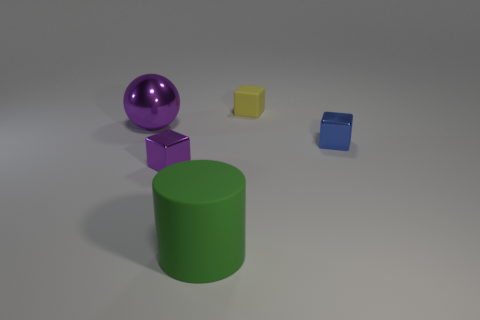How many cyan objects are tiny shiny cubes or metallic objects?
Offer a terse response. 0. The ball has what color?
Provide a short and direct response. Purple. Are there any other things that are the same material as the yellow object?
Keep it short and to the point. Yes. Is the number of cylinders in front of the green rubber cylinder less than the number of yellow rubber blocks that are on the left side of the large metallic thing?
Keep it short and to the point. No. The object that is both in front of the tiny blue thing and behind the matte cylinder has what shape?
Ensure brevity in your answer.  Cube. How many purple metal objects are the same shape as the tiny yellow rubber object?
Give a very brief answer. 1. The ball that is the same material as the blue object is what size?
Your answer should be very brief. Large. How many other blocks are the same size as the matte block?
Make the answer very short. 2. The shiny block that is the same color as the metallic sphere is what size?
Your answer should be compact. Small. There is a tiny metallic cube that is to the right of the purple thing in front of the large purple shiny sphere; what is its color?
Offer a terse response. Blue. 